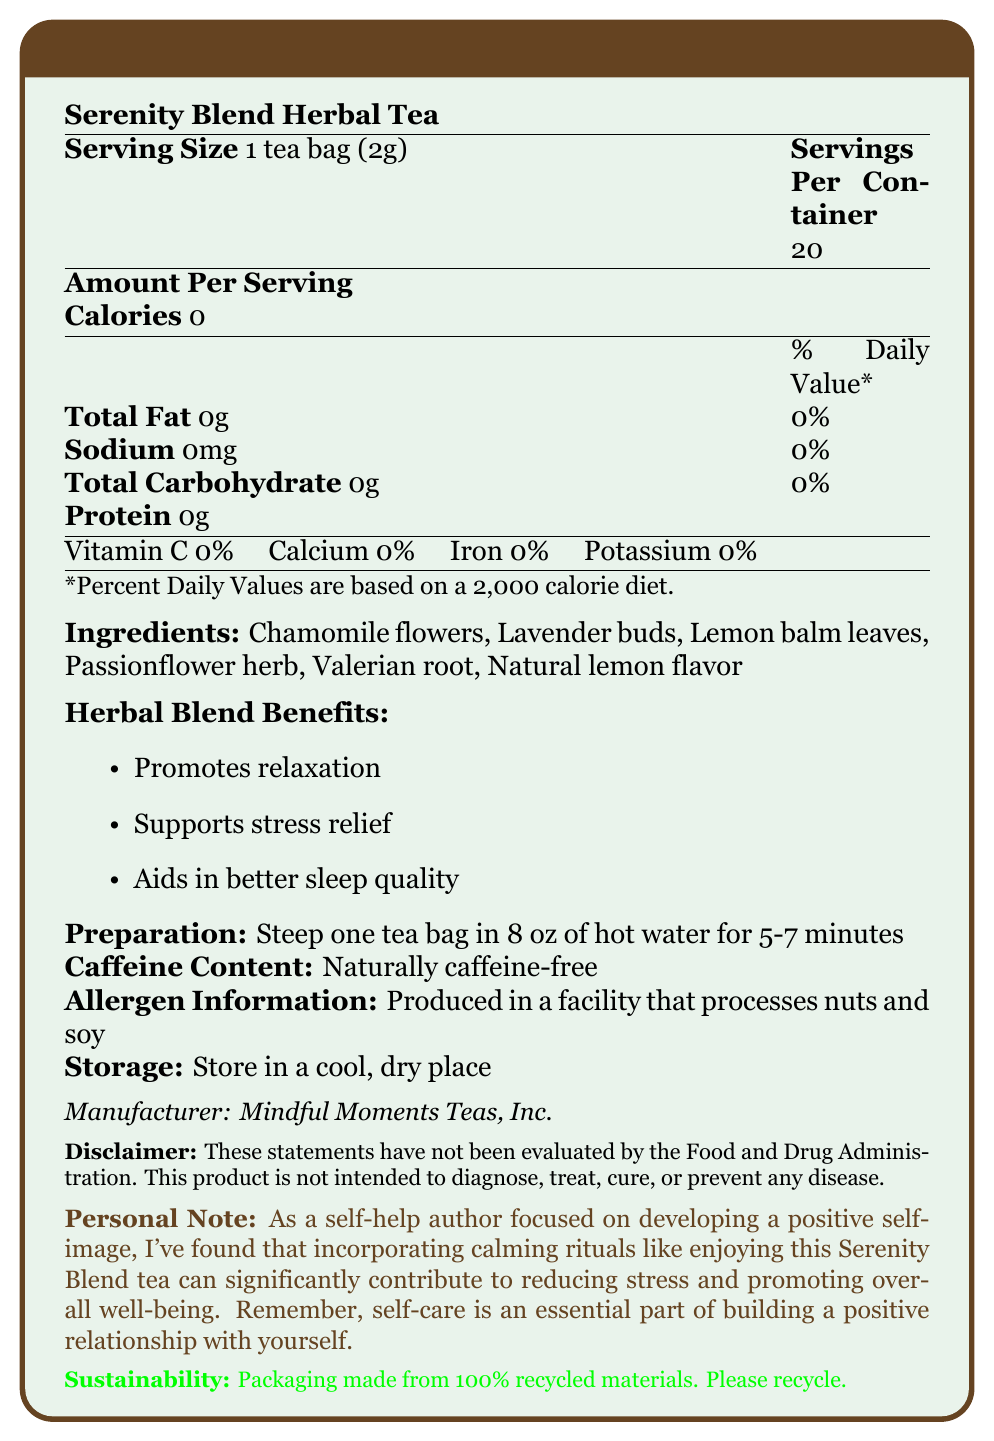what is the serving size? The serving size is explicitly mentioned as "1 tea bag (2g)" in the document.
Answer: 1 tea bag (2g) how many servings are there per container? The document states that there are 20 servings per container.
Answer: 20 are there any calories in this tea? The document states that the tea has 0 calories.
Answer: No what are the main ingredients in the Serenity Blend Herbal Tea? The list of ingredients is provided in the document.
Answer: Chamomile flowers, Lavender buds, Lemon balm leaves, Passionflower herb, Valerian root, and Natural lemon flavor what are the stated benefits of this herbal blend? The document lists these benefits under "Herbal Blend Benefits."
Answer: Promotes relaxation, Supports stress relief, Aids in better sleep quality what is the caffeine content in this tea? The document states that the tea is naturally caffeine-free.
Answer: Naturally caffeine-free what should you do to prepare a cup of this tea? The document gives these instructions under "Preparation."
Answer: Steep one tea bag in 8 oz of hot water for 5-7 minutes does this product contain any allergens? The document mentions this in the "Allergen Information" section.
Answer: Produced in a facility that processes nuts and soy how should this tea be stored? The document states to store the tea in a cool, dry place.
Answer: In a cool, dry place who is the manufacturer of this tea? The manufacturer information is listed at the bottom of the document.
Answer: Mindful Moments Teas, Inc. what is the contact information for the manufacturer? The contact information is provided in the document.
Answer: www.mindfulmomentsteas.com what disclaimer is included in the document regarding the product? This disclaimer is mentioned in the document.
Answer: These statements have not been evaluated by the Food and Drug Administration. This product is not intended to diagnose, treat, cure, or prevent any disease. which vitamin or mineral does this tea contain? A. Vitamin A B. Vitamin B C. Vitamin C D. Iron The document lists Vitamin C with a value of 0%, indicating its presence.
Answer: C. Vitamin C which of the following is NOT an ingredient in Serenity Blend Herbal Tea? A. Chamomile flowers B. Lavender buds C. Jasmine flowers D. Lemon balm leaves Chamomile flowers, Lavender buds, and Lemon balm leaves are listed as ingredients, but Jasmine flowers are not.
Answer: C. Jasmine flowers is this tea suitable for someone avoiding caffeine? The document states the tea is "naturally caffeine-free."
Answer: Yes summarize the main idea of the document. The document focuses on the nutritional facts, ingredients, benefits, preparation instructions, and other relevant information about the tea.
Answer: The Serenity Blend Herbal Tea provides a calming, stress-relieving, and sleep-enhancing experience without any calories, caffeine, or common allergens, and is produced by Mindful Moments Teas, Inc. does the document mention the exact percentage of daily values for vitamins and minerals? The document states 0% for Vitamin C, Calcium, Iron, and Potassium.
Answer: Yes how long should you steep the tea bag in hot water? The preparation instructions specify to steep the tea bag for 5-7 minutes.
Answer: 5-7 minutes what percentage of calcium is in this tea? The document states that the tea contains 0% calcium.
Answer: 0% can you determine the price of this tea from the document? The document does not provide any information regarding the price of the tea.
Answer: Not enough information 